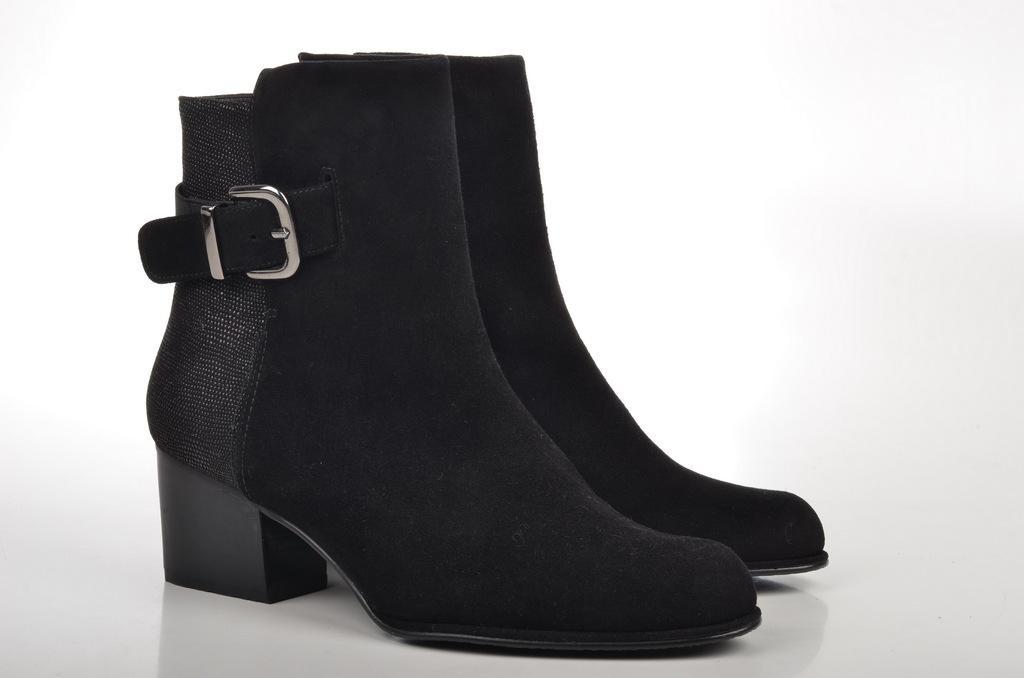Please provide a concise description of this image. In this image I can see the pair of shoe which are in black color. These are on the white color surface. 